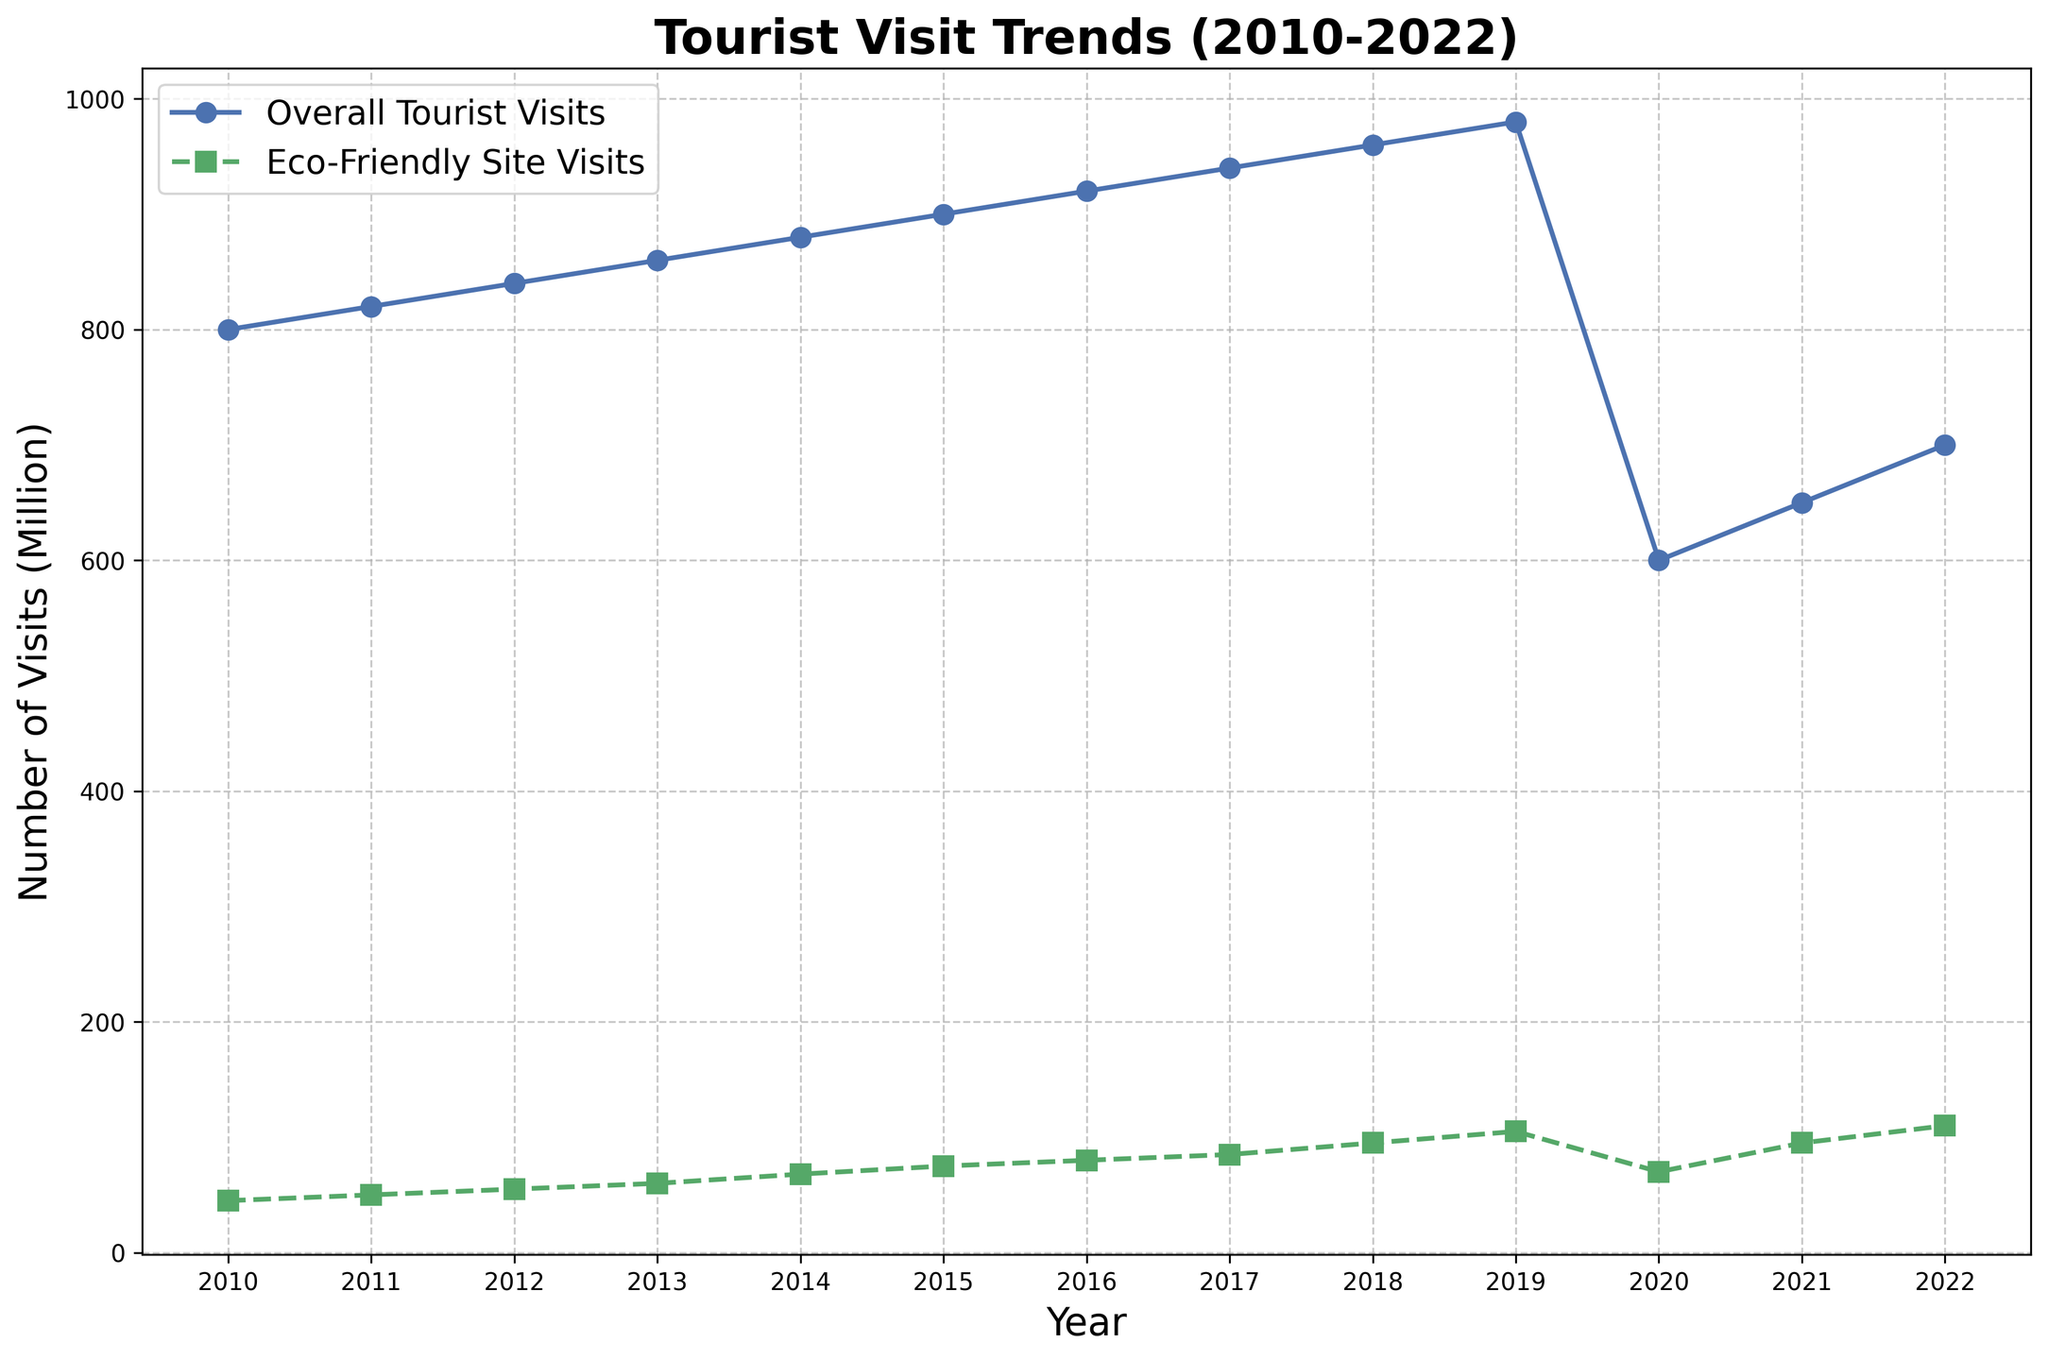What's the difference in tourist visits to eco-friendly sites between 2019 and 2020? The figure shows that in 2019, the eco-friendly site visits were 105 million, and in 2020, they were 70 million. The difference is calculated as 105 - 70.
Answer: 35 million Which year had the highest number of overall tourist visits? The figure shows the overall tourist visits. The peak value occurs at 2019 with 980 million visits.
Answer: 2019 How did the trend of eco-friendly site visits change after 2019? By observing the figure, eco-friendly site visits show a significant drop in 2020 from 105 to 70 million, then a substantial increase to 95 million in 2021, and further to 110 million in 2022.
Answer: Decreased in 2020, then increased in 2021 and 2022 Compare the growth rates of overall tourism and eco-friendly tourism from 2010 to 2019. Which had a higher growth rate? Calculating the growth rate, overall tourist visits grew from 800 million to 980 million (980 - 800 = 180 million). Eco-friendly site visits grew from 45 million to 105 million (105 - 45 = 60 million). To compare growth: 180/800 and 60/45, the growth rates are 22.5% and 133.3%.
Answer: Eco-friendly tourism In 2020, which type of tourism had a smaller decrease in the number of visits compared to 2019? The figure shows that the overall tourist visits dropped from 980 million to 600 million (a drop of 380 million), while eco-friendly site visits dropped from 105 million to 70 million (a drop of 35 million). Eco-friendly tourism had the smaller decrease.
Answer: Eco-friendly tourism What is the average number of visits to eco-friendly tourism sites from 2010 to 2022? Adding the values across the years: 45 + 50 + 55 + 60 + 68 + 75 + 80 + 85 + 95 + 105 + 70 + 95 + 110 = 993. Dividing by the number of years (13): 993 / 13 = 76.38 million.
Answer: 76.38 million 